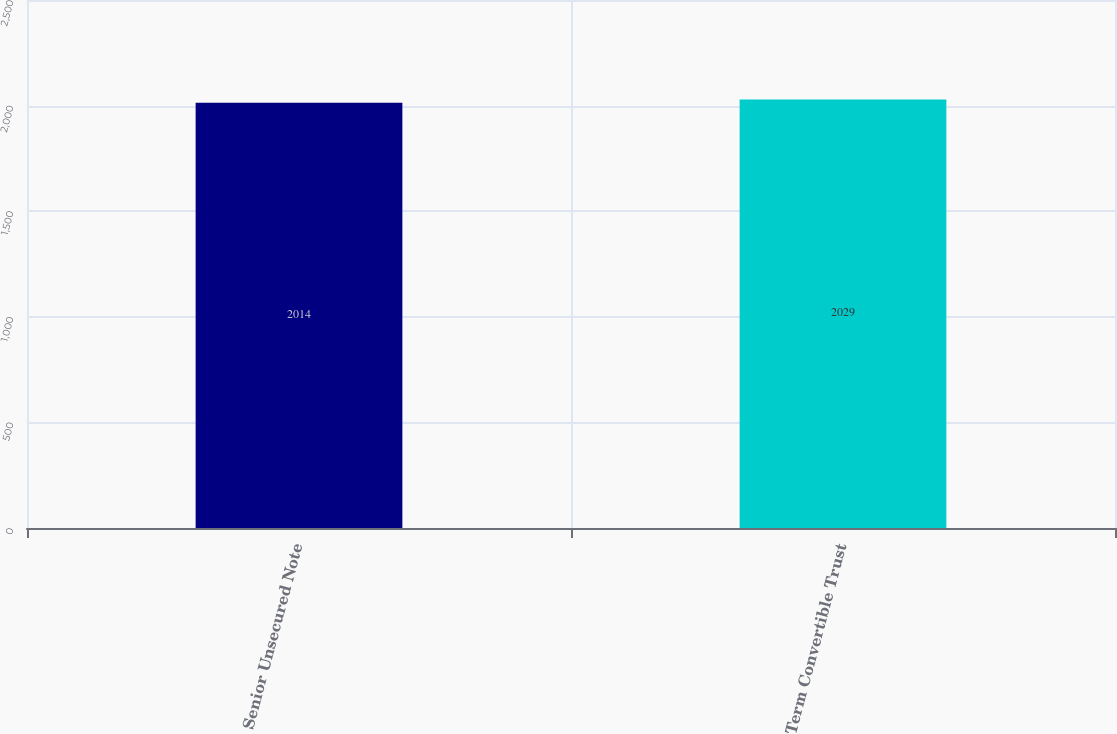<chart> <loc_0><loc_0><loc_500><loc_500><bar_chart><fcel>Senior Unsecured Note<fcel>Term Convertible Trust<nl><fcel>2014<fcel>2029<nl></chart> 